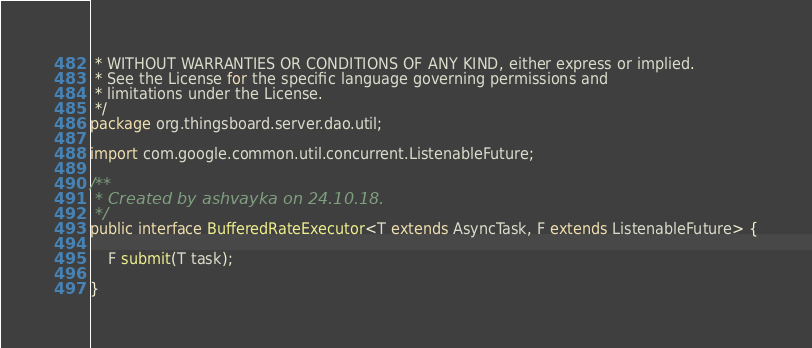Convert code to text. <code><loc_0><loc_0><loc_500><loc_500><_Java_> * WITHOUT WARRANTIES OR CONDITIONS OF ANY KIND, either express or implied.
 * See the License for the specific language governing permissions and
 * limitations under the License.
 */
package org.thingsboard.server.dao.util;

import com.google.common.util.concurrent.ListenableFuture;

/**
 * Created by ashvayka on 24.10.18.
 */
public interface BufferedRateExecutor<T extends AsyncTask, F extends ListenableFuture> {

    F submit(T task);

}
</code> 